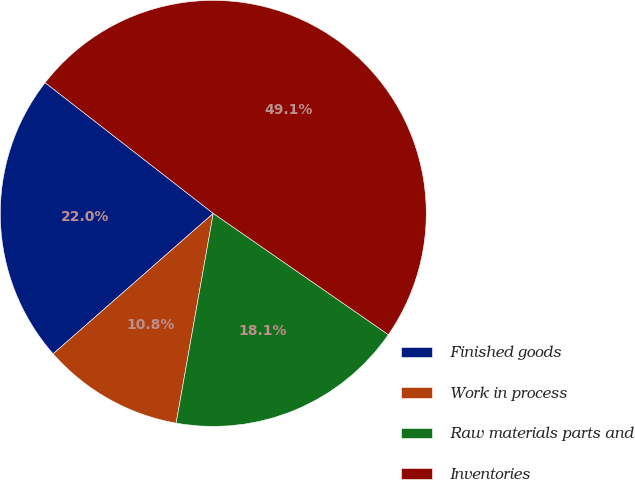<chart> <loc_0><loc_0><loc_500><loc_500><pie_chart><fcel>Finished goods<fcel>Work in process<fcel>Raw materials parts and<fcel>Inventories<nl><fcel>21.98%<fcel>10.75%<fcel>18.15%<fcel>49.12%<nl></chart> 